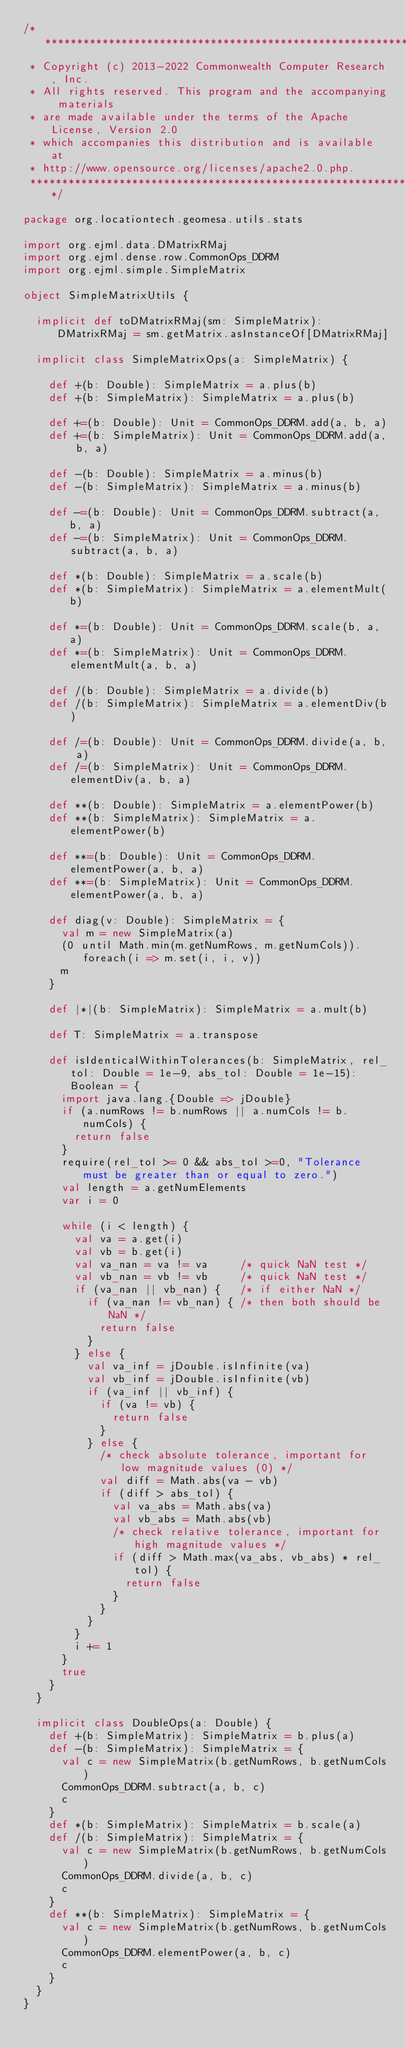Convert code to text. <code><loc_0><loc_0><loc_500><loc_500><_Scala_>/***********************************************************************
 * Copyright (c) 2013-2022 Commonwealth Computer Research, Inc.
 * All rights reserved. This program and the accompanying materials
 * are made available under the terms of the Apache License, Version 2.0
 * which accompanies this distribution and is available at
 * http://www.opensource.org/licenses/apache2.0.php.
 ***********************************************************************/

package org.locationtech.geomesa.utils.stats

import org.ejml.data.DMatrixRMaj
import org.ejml.dense.row.CommonOps_DDRM
import org.ejml.simple.SimpleMatrix

object SimpleMatrixUtils {

  implicit def toDMatrixRMaj(sm: SimpleMatrix): DMatrixRMaj = sm.getMatrix.asInstanceOf[DMatrixRMaj]

  implicit class SimpleMatrixOps(a: SimpleMatrix) {

    def +(b: Double): SimpleMatrix = a.plus(b)
    def +(b: SimpleMatrix): SimpleMatrix = a.plus(b)

    def +=(b: Double): Unit = CommonOps_DDRM.add(a, b, a)
    def +=(b: SimpleMatrix): Unit = CommonOps_DDRM.add(a, b, a)

    def -(b: Double): SimpleMatrix = a.minus(b)
    def -(b: SimpleMatrix): SimpleMatrix = a.minus(b)

    def -=(b: Double): Unit = CommonOps_DDRM.subtract(a, b, a)
    def -=(b: SimpleMatrix): Unit = CommonOps_DDRM.subtract(a, b, a)

    def *(b: Double): SimpleMatrix = a.scale(b)
    def *(b: SimpleMatrix): SimpleMatrix = a.elementMult(b)

    def *=(b: Double): Unit = CommonOps_DDRM.scale(b, a, a)
    def *=(b: SimpleMatrix): Unit = CommonOps_DDRM.elementMult(a, b, a)

    def /(b: Double): SimpleMatrix = a.divide(b)
    def /(b: SimpleMatrix): SimpleMatrix = a.elementDiv(b)

    def /=(b: Double): Unit = CommonOps_DDRM.divide(a, b, a)
    def /=(b: SimpleMatrix): Unit = CommonOps_DDRM.elementDiv(a, b, a)

    def **(b: Double): SimpleMatrix = a.elementPower(b)
    def **(b: SimpleMatrix): SimpleMatrix = a.elementPower(b)

    def **=(b: Double): Unit = CommonOps_DDRM.elementPower(a, b, a)
    def **=(b: SimpleMatrix): Unit = CommonOps_DDRM.elementPower(a, b, a)

    def diag(v: Double): SimpleMatrix = {
      val m = new SimpleMatrix(a)
      (0 until Math.min(m.getNumRows, m.getNumCols)).foreach(i => m.set(i, i, v))
      m
    }

    def |*|(b: SimpleMatrix): SimpleMatrix = a.mult(b)

    def T: SimpleMatrix = a.transpose

    def isIdenticalWithinTolerances(b: SimpleMatrix, rel_tol: Double = 1e-9, abs_tol: Double = 1e-15): Boolean = {
      import java.lang.{Double => jDouble}
      if (a.numRows != b.numRows || a.numCols != b.numCols) {
        return false
      }
      require(rel_tol >= 0 && abs_tol >=0, "Tolerance must be greater than or equal to zero.")
      val length = a.getNumElements
      var i = 0

      while (i < length) {
        val va = a.get(i)
        val vb = b.get(i)
        val va_nan = va != va     /* quick NaN test */
        val vb_nan = vb != vb     /* quick NaN test */
        if (va_nan || vb_nan) {   /* if either NaN */
          if (va_nan != vb_nan) { /* then both should be NaN */
            return false
          }
        } else {
          val va_inf = jDouble.isInfinite(va)
          val vb_inf = jDouble.isInfinite(vb)
          if (va_inf || vb_inf) {
            if (va != vb) {
              return false
            }
          } else {
            /* check absolute tolerance, important for low magnitude values (0) */
            val diff = Math.abs(va - vb)
            if (diff > abs_tol) {
              val va_abs = Math.abs(va)
              val vb_abs = Math.abs(vb)
              /* check relative tolerance, important for high magnitude values */
              if (diff > Math.max(va_abs, vb_abs) * rel_tol) {
                return false
              }
            }
          }
        }
        i += 1
      }
      true
    }
  }

  implicit class DoubleOps(a: Double) {
    def +(b: SimpleMatrix): SimpleMatrix = b.plus(a)
    def -(b: SimpleMatrix): SimpleMatrix = {
      val c = new SimpleMatrix(b.getNumRows, b.getNumCols)
      CommonOps_DDRM.subtract(a, b, c)
      c
    }
    def *(b: SimpleMatrix): SimpleMatrix = b.scale(a)
    def /(b: SimpleMatrix): SimpleMatrix = {
      val c = new SimpleMatrix(b.getNumRows, b.getNumCols)
      CommonOps_DDRM.divide(a, b, c)
      c
    }
    def **(b: SimpleMatrix): SimpleMatrix = {
      val c = new SimpleMatrix(b.getNumRows, b.getNumCols)
      CommonOps_DDRM.elementPower(a, b, c)
      c
    }
  }
}
</code> 